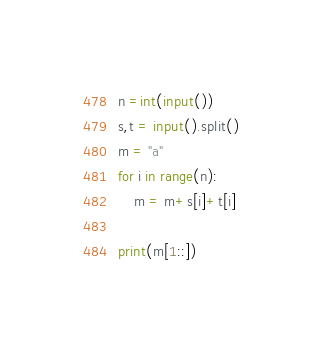<code> <loc_0><loc_0><loc_500><loc_500><_Python_>n =int(input())
s,t = input().split()
m = "a"
for i in range(n):
    m = m+s[i]+t[i]

print(m[1::])
</code> 